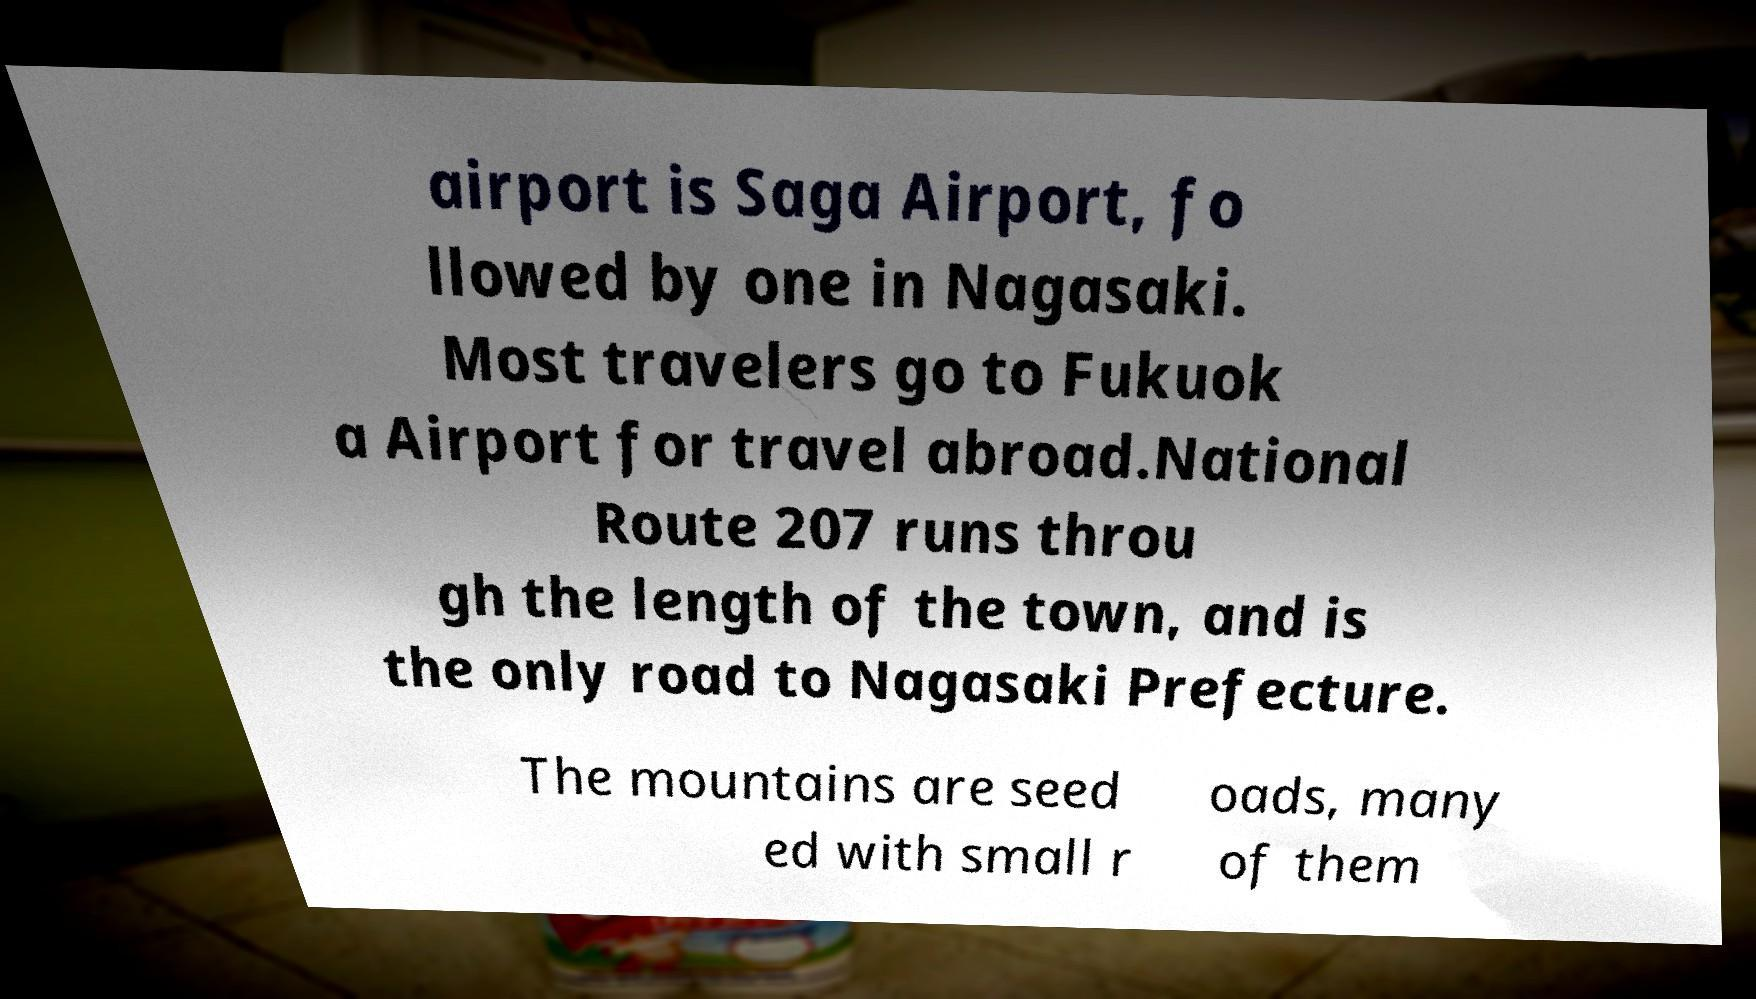What messages or text are displayed in this image? I need them in a readable, typed format. airport is Saga Airport, fo llowed by one in Nagasaki. Most travelers go to Fukuok a Airport for travel abroad.National Route 207 runs throu gh the length of the town, and is the only road to Nagasaki Prefecture. The mountains are seed ed with small r oads, many of them 